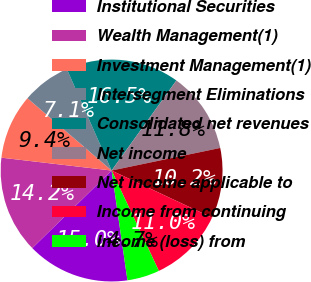Convert chart. <chart><loc_0><loc_0><loc_500><loc_500><pie_chart><fcel>Institutional Securities<fcel>Wealth Management(1)<fcel>Investment Management(1)<fcel>Intersegment Eliminations<fcel>Consolidated net revenues<fcel>Net income<fcel>Net income applicable to<fcel>Income from continuing<fcel>Income (loss) from<nl><fcel>14.96%<fcel>14.17%<fcel>9.45%<fcel>7.09%<fcel>16.54%<fcel>11.81%<fcel>10.24%<fcel>11.02%<fcel>4.72%<nl></chart> 